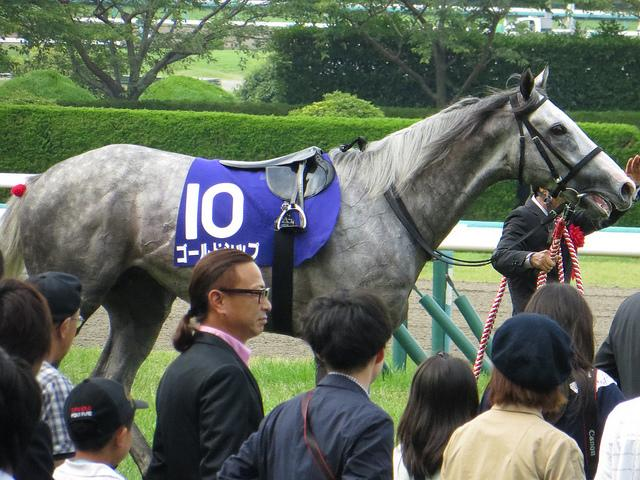What does the number ten indicate?

Choices:
A) starting position
B) betting odds
C) his age
D) his ranking starting position 